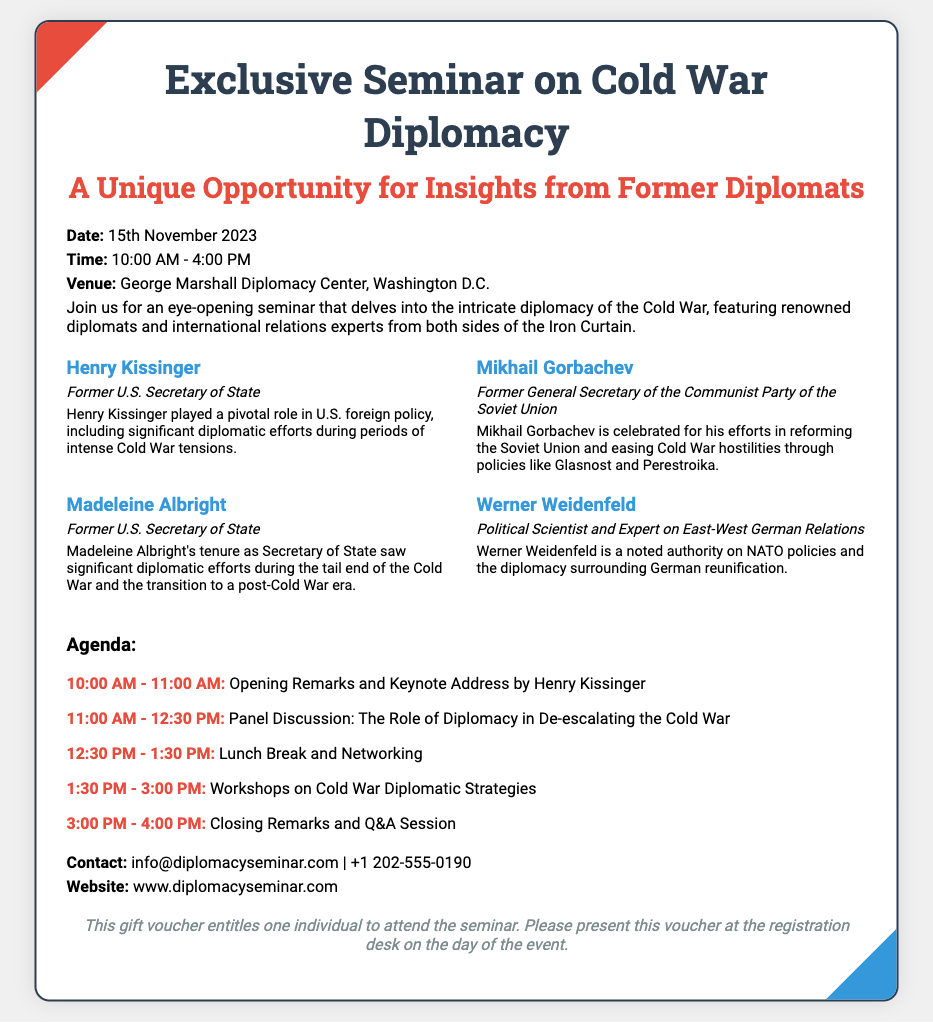What is the date of the seminar? The date of the seminar is clearly stated in the event details section of the document.
Answer: 15th November 2023 Who is the keynote speaker at the seminar? The keynote speaker is mentioned in the agenda section for the opening remarks.
Answer: Henry Kissinger What time does the seminar start? The starting time is indicated in the event details and agenda section of the document.
Answer: 10:00 AM Which venue is hosting the seminar? The hosting venue is mentioned in the event details section.
Answer: George Marshall Diplomacy Center, Washington D.C What is the theme of the panel discussion? The theme of the panel discussion is outlined in the agenda section of the document.
Answer: The Role of Diplomacy in De-escalating the Cold War Who are the speakers at the seminar? The speakers are listed in the speakers section, including their titles and roles.
Answer: Henry Kissinger, Mikhail Gorbachev, Madeleine Albright, Werner Weidenfeld How long is the lunch break? The duration of the lunch break is mentioned in the agenda section.
Answer: 1 hour What is the contact email for the seminar? The contact email is provided in the extra information section of the document.
Answer: info@diplomacyseminar.com What does the gift voucher entitle the holder to? The entitlements of the gift voucher are stated at the end of the document.
Answer: Attend the seminar 